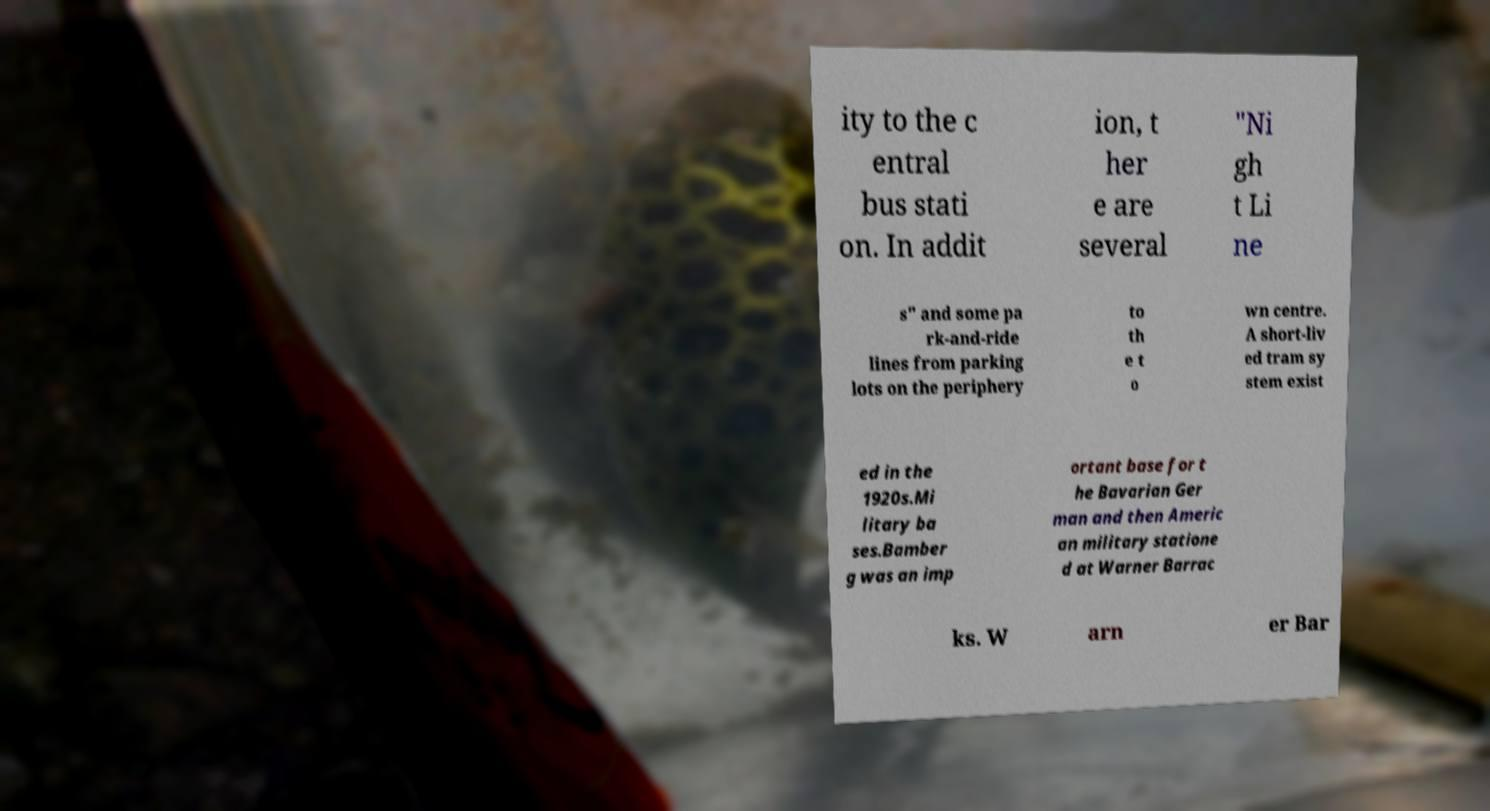I need the written content from this picture converted into text. Can you do that? ity to the c entral bus stati on. In addit ion, t her e are several "Ni gh t Li ne s" and some pa rk-and-ride lines from parking lots on the periphery to th e t o wn centre. A short-liv ed tram sy stem exist ed in the 1920s.Mi litary ba ses.Bamber g was an imp ortant base for t he Bavarian Ger man and then Americ an military statione d at Warner Barrac ks. W arn er Bar 